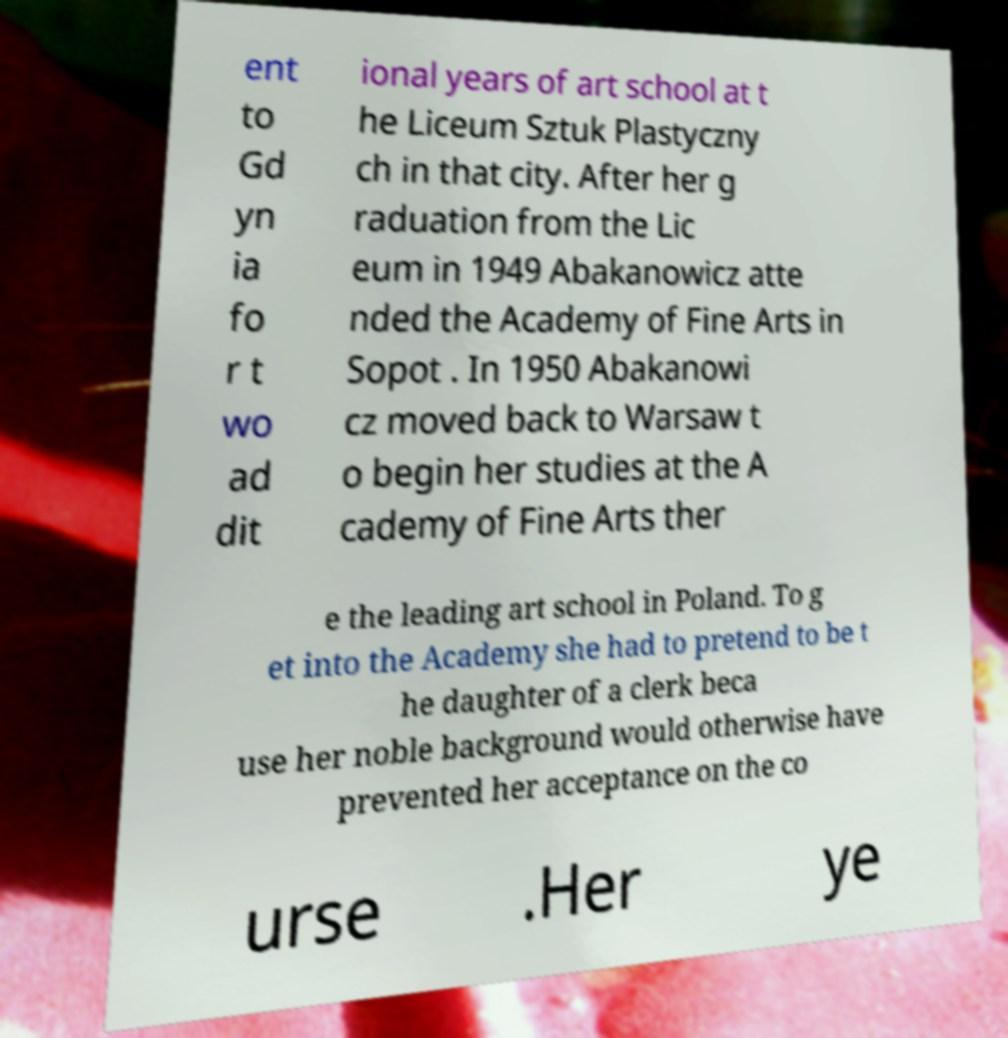Please read and relay the text visible in this image. What does it say? ent to Gd yn ia fo r t wo ad dit ional years of art school at t he Liceum Sztuk Plastyczny ch in that city. After her g raduation from the Lic eum in 1949 Abakanowicz atte nded the Academy of Fine Arts in Sopot . In 1950 Abakanowi cz moved back to Warsaw t o begin her studies at the A cademy of Fine Arts ther e the leading art school in Poland. To g et into the Academy she had to pretend to be t he daughter of a clerk beca use her noble background would otherwise have prevented her acceptance on the co urse .Her ye 